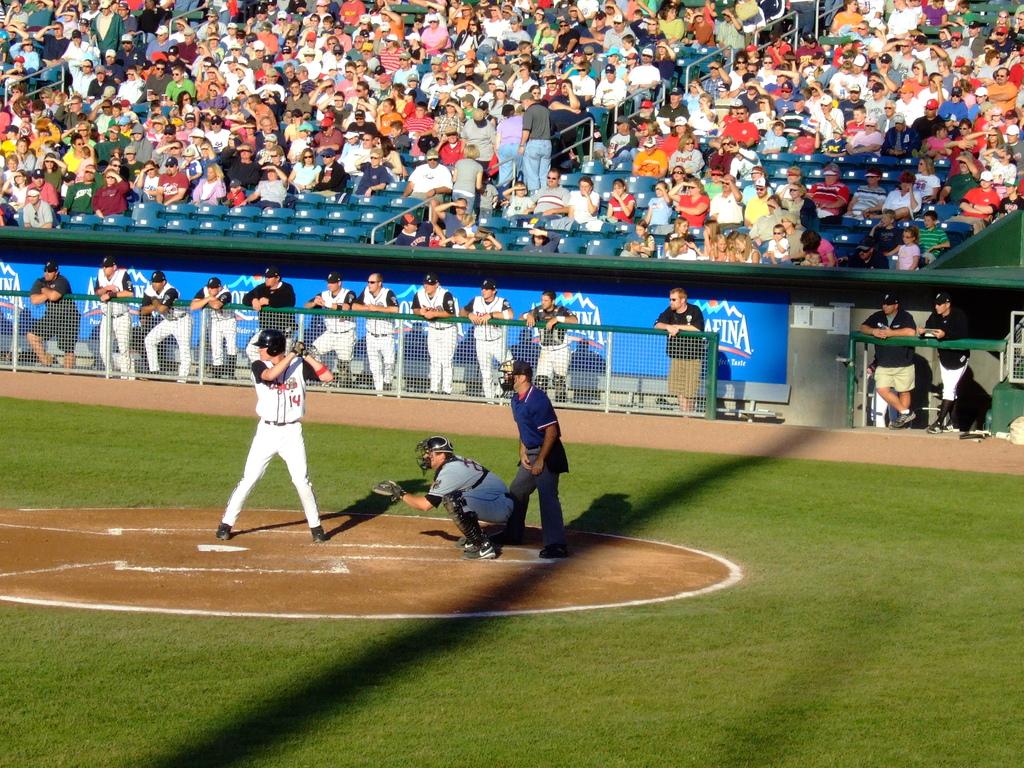What number can be seen in the man's jersey?
Offer a very short reply. 14. 